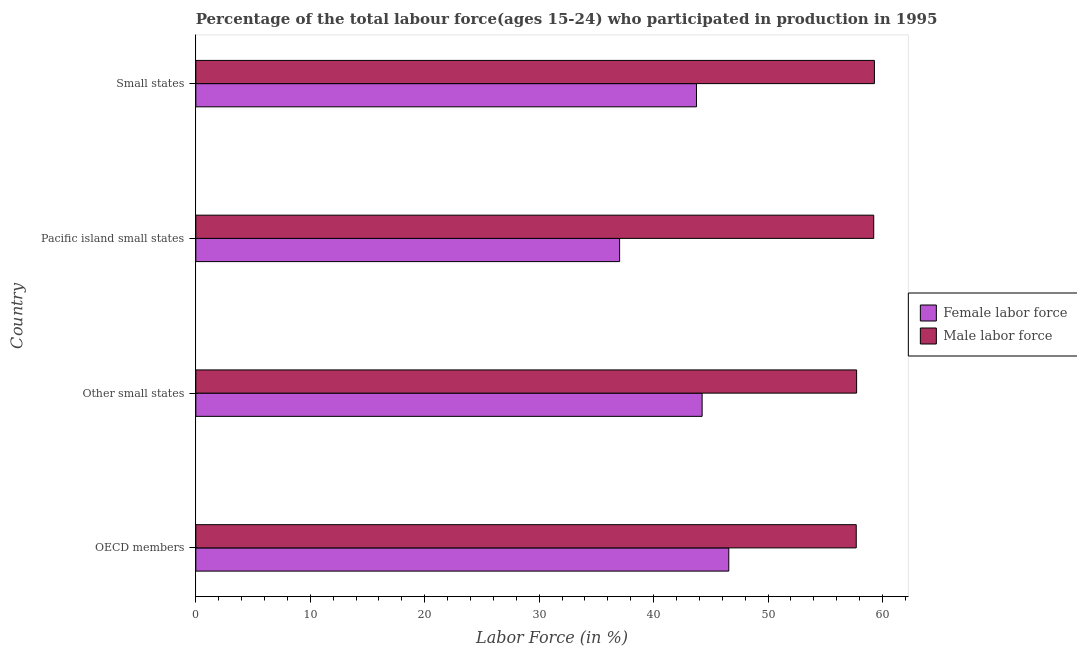How many groups of bars are there?
Keep it short and to the point. 4. Are the number of bars per tick equal to the number of legend labels?
Provide a succinct answer. Yes. Are the number of bars on each tick of the Y-axis equal?
Keep it short and to the point. Yes. How many bars are there on the 4th tick from the top?
Provide a short and direct response. 2. What is the label of the 2nd group of bars from the top?
Your answer should be compact. Pacific island small states. What is the percentage of male labour force in OECD members?
Your response must be concise. 57.7. Across all countries, what is the maximum percentage of female labor force?
Offer a terse response. 46.57. Across all countries, what is the minimum percentage of male labour force?
Your response must be concise. 57.7. In which country was the percentage of male labour force maximum?
Your response must be concise. Small states. In which country was the percentage of female labor force minimum?
Give a very brief answer. Pacific island small states. What is the total percentage of male labour force in the graph?
Provide a succinct answer. 233.96. What is the difference between the percentage of male labour force in OECD members and that in Small states?
Your answer should be very brief. -1.59. What is the difference between the percentage of female labor force in Small states and the percentage of male labour force in OECD members?
Your response must be concise. -13.96. What is the average percentage of male labour force per country?
Provide a succinct answer. 58.49. What is the difference between the percentage of male labour force and percentage of female labor force in Small states?
Offer a very short reply. 15.55. In how many countries, is the percentage of female labor force greater than 10 %?
Offer a very short reply. 4. What is the ratio of the percentage of female labor force in OECD members to that in Pacific island small states?
Your response must be concise. 1.26. Is the difference between the percentage of female labor force in OECD members and Other small states greater than the difference between the percentage of male labour force in OECD members and Other small states?
Provide a short and direct response. Yes. What is the difference between the highest and the second highest percentage of male labour force?
Keep it short and to the point. 0.06. What is the difference between the highest and the lowest percentage of male labour force?
Your response must be concise. 1.59. What does the 1st bar from the top in OECD members represents?
Your answer should be very brief. Male labor force. What does the 1st bar from the bottom in Other small states represents?
Give a very brief answer. Female labor force. How many bars are there?
Offer a terse response. 8. Are all the bars in the graph horizontal?
Offer a very short reply. Yes. How many countries are there in the graph?
Your answer should be compact. 4. Are the values on the major ticks of X-axis written in scientific E-notation?
Offer a terse response. No. How are the legend labels stacked?
Offer a terse response. Vertical. What is the title of the graph?
Make the answer very short. Percentage of the total labour force(ages 15-24) who participated in production in 1995. What is the label or title of the Y-axis?
Provide a short and direct response. Country. What is the Labor Force (in %) of Female labor force in OECD members?
Ensure brevity in your answer.  46.57. What is the Labor Force (in %) in Male labor force in OECD members?
Offer a terse response. 57.7. What is the Labor Force (in %) of Female labor force in Other small states?
Give a very brief answer. 44.24. What is the Labor Force (in %) in Male labor force in Other small states?
Your answer should be compact. 57.74. What is the Labor Force (in %) in Female labor force in Pacific island small states?
Offer a terse response. 37.03. What is the Labor Force (in %) of Male labor force in Pacific island small states?
Provide a short and direct response. 59.23. What is the Labor Force (in %) in Female labor force in Small states?
Your response must be concise. 43.75. What is the Labor Force (in %) of Male labor force in Small states?
Ensure brevity in your answer.  59.29. Across all countries, what is the maximum Labor Force (in %) in Female labor force?
Your answer should be very brief. 46.57. Across all countries, what is the maximum Labor Force (in %) of Male labor force?
Offer a terse response. 59.29. Across all countries, what is the minimum Labor Force (in %) of Female labor force?
Make the answer very short. 37.03. Across all countries, what is the minimum Labor Force (in %) of Male labor force?
Make the answer very short. 57.7. What is the total Labor Force (in %) of Female labor force in the graph?
Make the answer very short. 171.58. What is the total Labor Force (in %) of Male labor force in the graph?
Your answer should be very brief. 233.96. What is the difference between the Labor Force (in %) of Female labor force in OECD members and that in Other small states?
Provide a short and direct response. 2.33. What is the difference between the Labor Force (in %) in Male labor force in OECD members and that in Other small states?
Make the answer very short. -0.03. What is the difference between the Labor Force (in %) of Female labor force in OECD members and that in Pacific island small states?
Give a very brief answer. 9.54. What is the difference between the Labor Force (in %) in Male labor force in OECD members and that in Pacific island small states?
Your answer should be compact. -1.53. What is the difference between the Labor Force (in %) in Female labor force in OECD members and that in Small states?
Your answer should be very brief. 2.82. What is the difference between the Labor Force (in %) in Male labor force in OECD members and that in Small states?
Give a very brief answer. -1.59. What is the difference between the Labor Force (in %) of Female labor force in Other small states and that in Pacific island small states?
Offer a terse response. 7.21. What is the difference between the Labor Force (in %) of Male labor force in Other small states and that in Pacific island small states?
Your answer should be very brief. -1.5. What is the difference between the Labor Force (in %) in Female labor force in Other small states and that in Small states?
Give a very brief answer. 0.49. What is the difference between the Labor Force (in %) of Male labor force in Other small states and that in Small states?
Give a very brief answer. -1.56. What is the difference between the Labor Force (in %) of Female labor force in Pacific island small states and that in Small states?
Provide a short and direct response. -6.72. What is the difference between the Labor Force (in %) in Male labor force in Pacific island small states and that in Small states?
Your answer should be very brief. -0.06. What is the difference between the Labor Force (in %) in Female labor force in OECD members and the Labor Force (in %) in Male labor force in Other small states?
Offer a terse response. -11.17. What is the difference between the Labor Force (in %) of Female labor force in OECD members and the Labor Force (in %) of Male labor force in Pacific island small states?
Your answer should be very brief. -12.66. What is the difference between the Labor Force (in %) of Female labor force in OECD members and the Labor Force (in %) of Male labor force in Small states?
Keep it short and to the point. -12.72. What is the difference between the Labor Force (in %) in Female labor force in Other small states and the Labor Force (in %) in Male labor force in Pacific island small states?
Your answer should be compact. -14.99. What is the difference between the Labor Force (in %) of Female labor force in Other small states and the Labor Force (in %) of Male labor force in Small states?
Provide a short and direct response. -15.05. What is the difference between the Labor Force (in %) of Female labor force in Pacific island small states and the Labor Force (in %) of Male labor force in Small states?
Give a very brief answer. -22.26. What is the average Labor Force (in %) in Female labor force per country?
Provide a succinct answer. 42.89. What is the average Labor Force (in %) in Male labor force per country?
Your answer should be compact. 58.49. What is the difference between the Labor Force (in %) of Female labor force and Labor Force (in %) of Male labor force in OECD members?
Offer a terse response. -11.14. What is the difference between the Labor Force (in %) in Female labor force and Labor Force (in %) in Male labor force in Other small states?
Ensure brevity in your answer.  -13.5. What is the difference between the Labor Force (in %) of Female labor force and Labor Force (in %) of Male labor force in Pacific island small states?
Keep it short and to the point. -22.2. What is the difference between the Labor Force (in %) in Female labor force and Labor Force (in %) in Male labor force in Small states?
Provide a short and direct response. -15.55. What is the ratio of the Labor Force (in %) of Female labor force in OECD members to that in Other small states?
Provide a short and direct response. 1.05. What is the ratio of the Labor Force (in %) in Male labor force in OECD members to that in Other small states?
Your response must be concise. 1. What is the ratio of the Labor Force (in %) in Female labor force in OECD members to that in Pacific island small states?
Provide a succinct answer. 1.26. What is the ratio of the Labor Force (in %) in Male labor force in OECD members to that in Pacific island small states?
Provide a short and direct response. 0.97. What is the ratio of the Labor Force (in %) in Female labor force in OECD members to that in Small states?
Your response must be concise. 1.06. What is the ratio of the Labor Force (in %) in Male labor force in OECD members to that in Small states?
Provide a succinct answer. 0.97. What is the ratio of the Labor Force (in %) in Female labor force in Other small states to that in Pacific island small states?
Ensure brevity in your answer.  1.19. What is the ratio of the Labor Force (in %) in Male labor force in Other small states to that in Pacific island small states?
Your answer should be very brief. 0.97. What is the ratio of the Labor Force (in %) of Female labor force in Other small states to that in Small states?
Provide a succinct answer. 1.01. What is the ratio of the Labor Force (in %) in Male labor force in Other small states to that in Small states?
Your answer should be very brief. 0.97. What is the ratio of the Labor Force (in %) in Female labor force in Pacific island small states to that in Small states?
Provide a succinct answer. 0.85. What is the difference between the highest and the second highest Labor Force (in %) in Female labor force?
Keep it short and to the point. 2.33. What is the difference between the highest and the second highest Labor Force (in %) of Male labor force?
Your response must be concise. 0.06. What is the difference between the highest and the lowest Labor Force (in %) of Female labor force?
Keep it short and to the point. 9.54. What is the difference between the highest and the lowest Labor Force (in %) of Male labor force?
Ensure brevity in your answer.  1.59. 